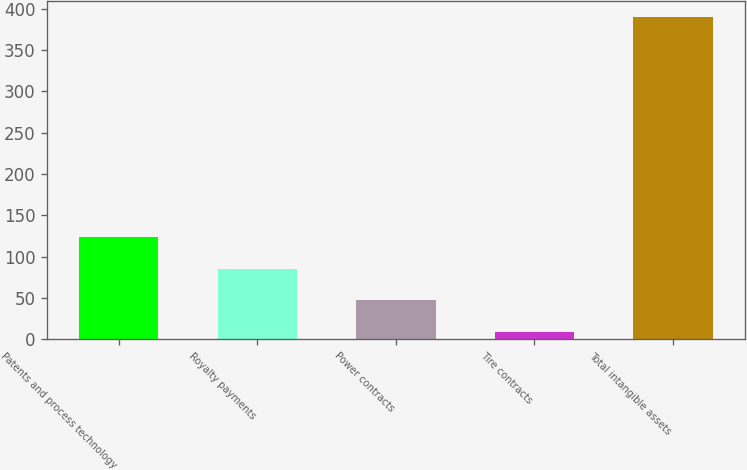Convert chart to OTSL. <chart><loc_0><loc_0><loc_500><loc_500><bar_chart><fcel>Patents and process technology<fcel>Royalty payments<fcel>Power contracts<fcel>Tire contracts<fcel>Total intangible assets<nl><fcel>123.3<fcel>85.2<fcel>47.1<fcel>9<fcel>390<nl></chart> 